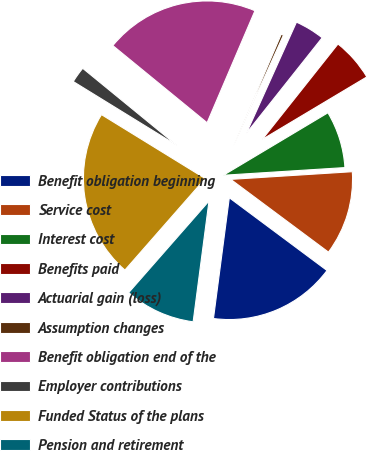Convert chart to OTSL. <chart><loc_0><loc_0><loc_500><loc_500><pie_chart><fcel>Benefit obligation beginning<fcel>Service cost<fcel>Interest cost<fcel>Benefits paid<fcel>Actuarial gain (loss)<fcel>Assumption changes<fcel>Benefit obligation end of the<fcel>Employer contributions<fcel>Funded Status of the plans<fcel>Pension and retirement<nl><fcel>16.89%<fcel>11.19%<fcel>7.57%<fcel>5.75%<fcel>3.94%<fcel>0.31%<fcel>20.51%<fcel>2.13%<fcel>22.33%<fcel>9.38%<nl></chart> 